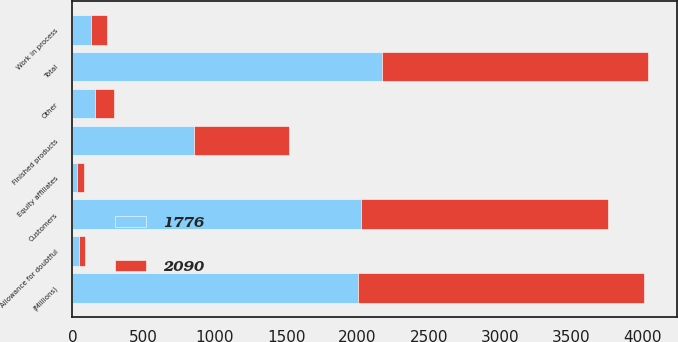Convert chart. <chart><loc_0><loc_0><loc_500><loc_500><stacked_bar_chart><ecel><fcel>(Millions)<fcel>Customers<fcel>Equity affiliates<fcel>Other<fcel>Allowance for doubtful<fcel>Total<fcel>Finished products<fcel>Work in process<nl><fcel>1776<fcel>2006<fcel>2025<fcel>31<fcel>161<fcel>49<fcel>2168<fcel>850<fcel>129<nl><fcel>2090<fcel>2005<fcel>1728<fcel>54<fcel>128<fcel>39<fcel>1871<fcel>667<fcel>111<nl></chart> 